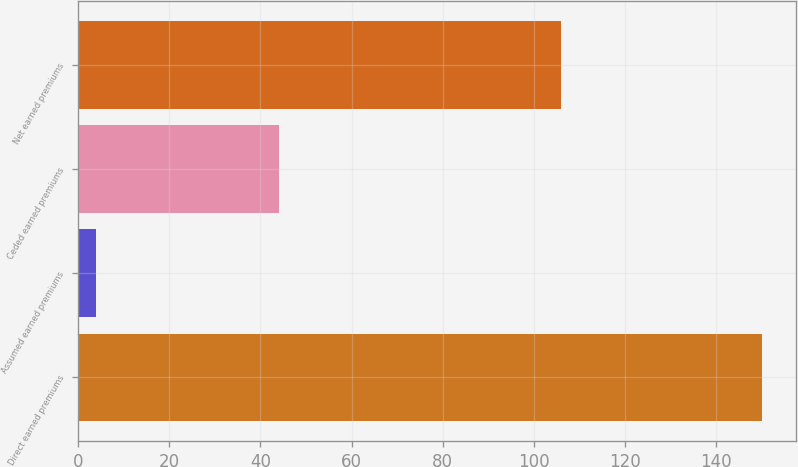Convert chart to OTSL. <chart><loc_0><loc_0><loc_500><loc_500><bar_chart><fcel>Direct earned premiums<fcel>Assumed earned premiums<fcel>Ceded earned premiums<fcel>Net earned premiums<nl><fcel>150<fcel>3.82<fcel>44<fcel>106<nl></chart> 